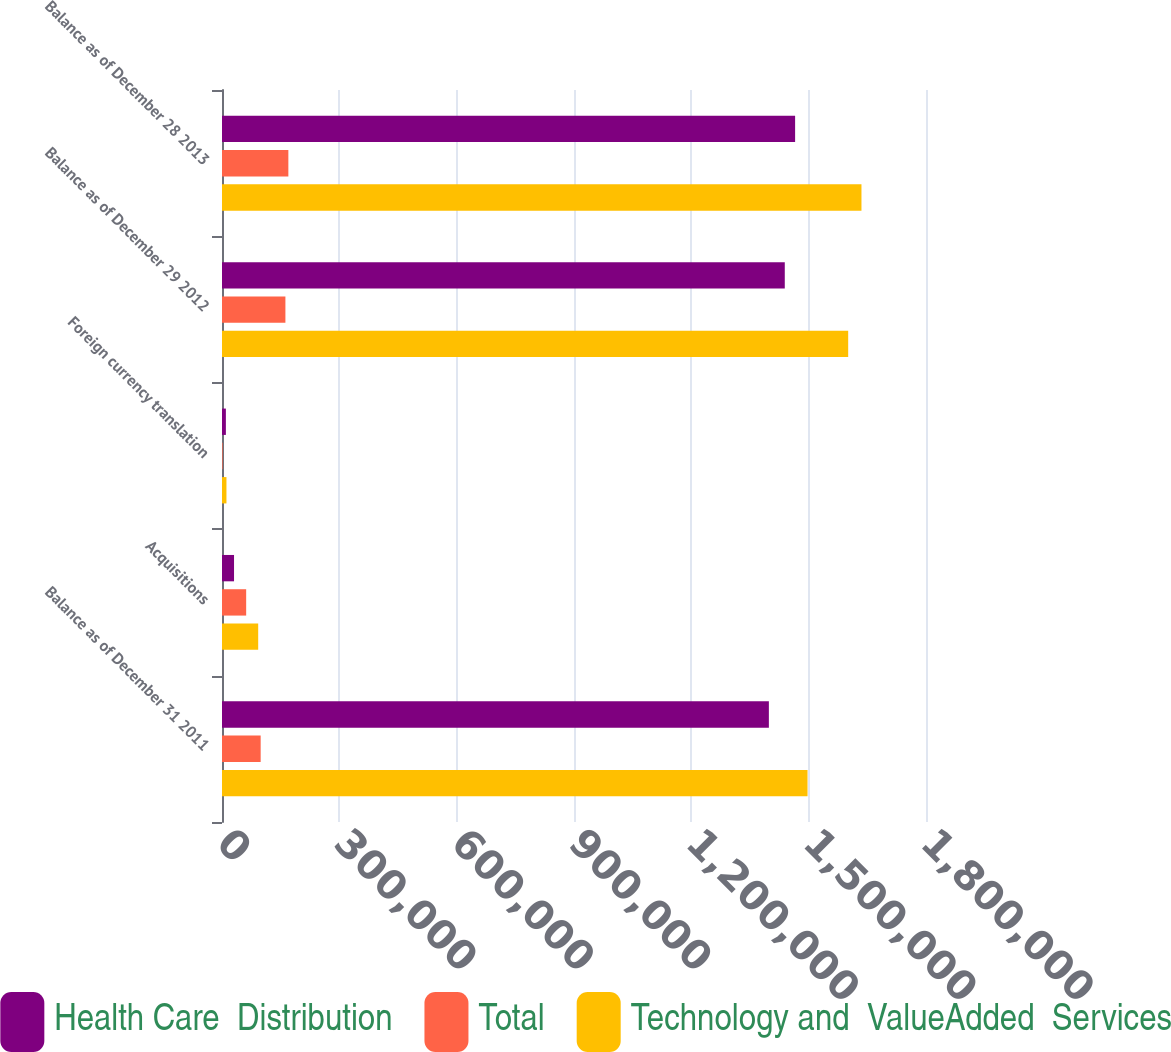Convert chart. <chart><loc_0><loc_0><loc_500><loc_500><stacked_bar_chart><ecel><fcel>Balance as of December 31 2011<fcel>Acquisitions<fcel>Foreign currency translation<fcel>Balance as of December 29 2012<fcel>Balance as of December 28 2013<nl><fcel>Health Care  Distribution<fcel>1.39825e+06<fcel>30765<fcel>9909<fcel>1.43892e+06<fcel>1.46534e+06<nl><fcel>Total<fcel>98860<fcel>61788<fcel>1476<fcel>162124<fcel>169667<nl><fcel>Technology and  ValueAdded  Services<fcel>1.49711e+06<fcel>92553<fcel>11385<fcel>1.60105e+06<fcel>1.635e+06<nl></chart> 